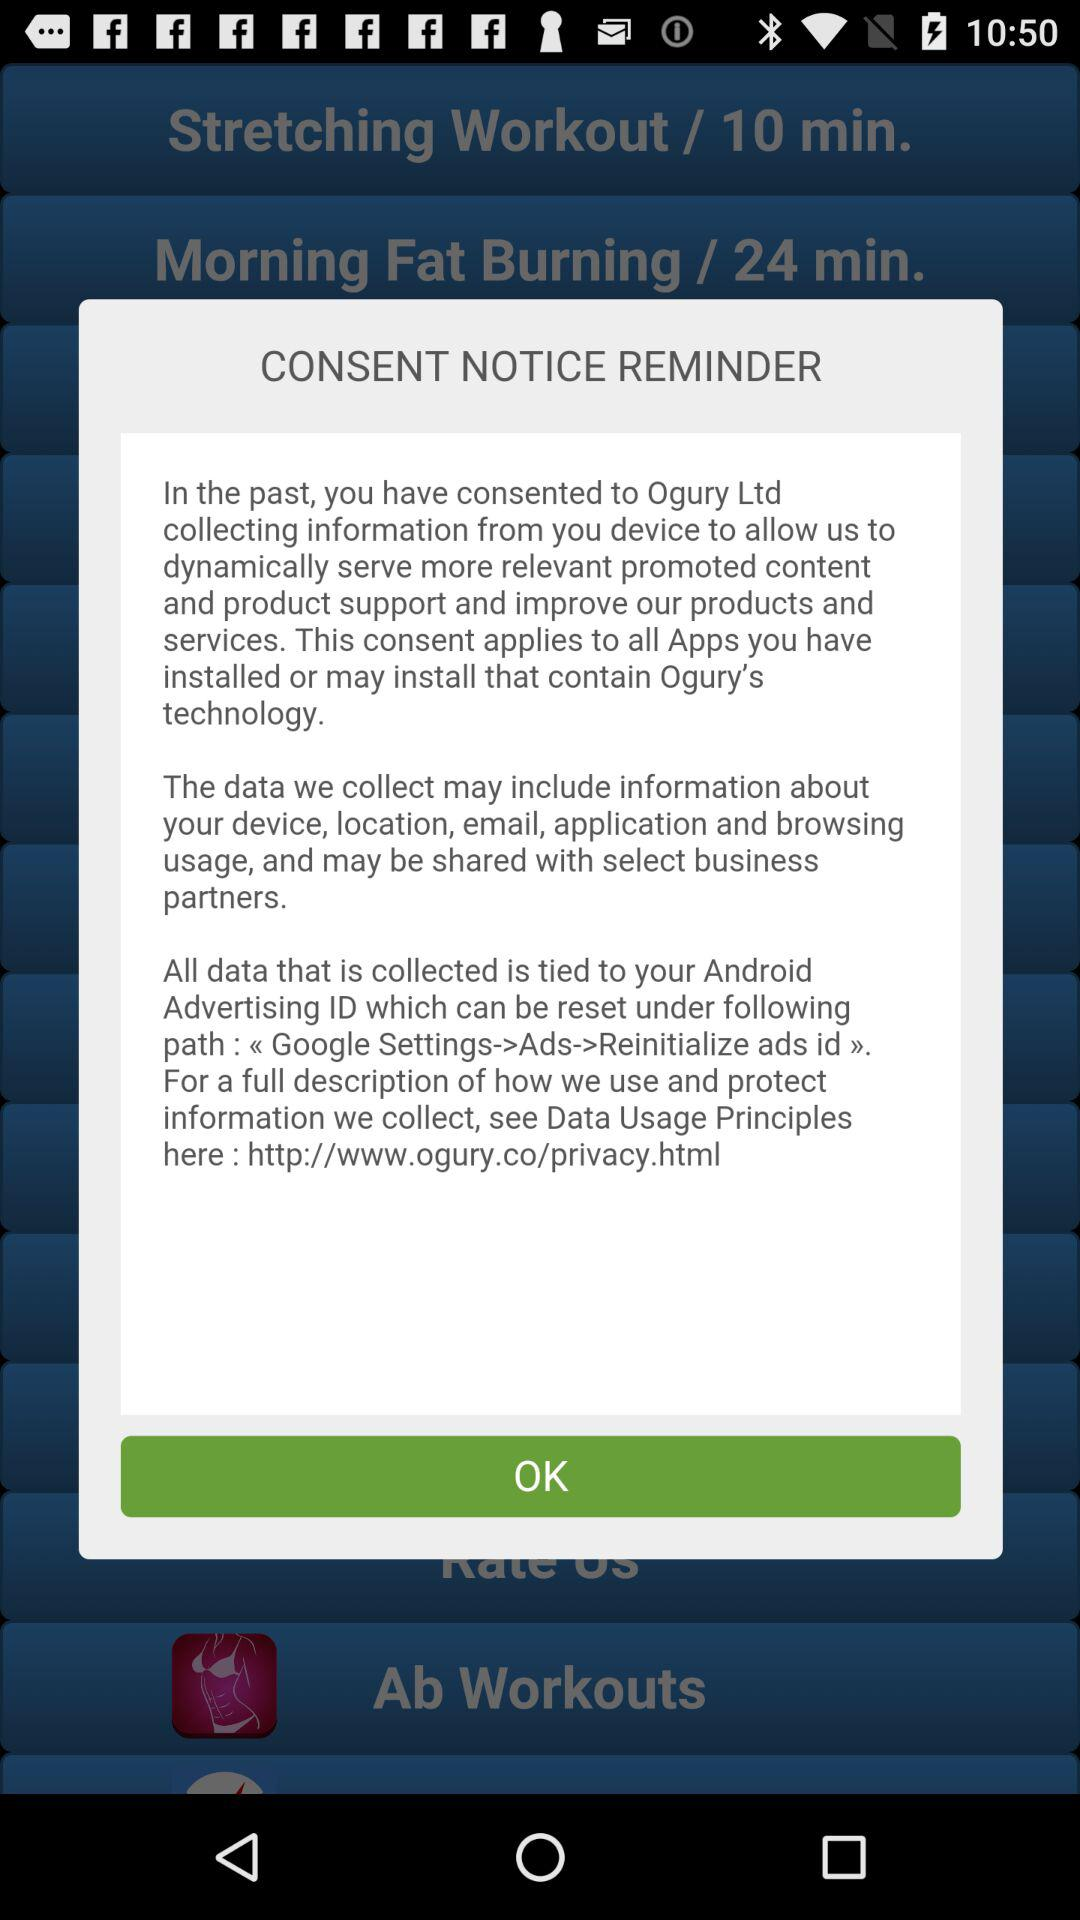Where will all data be collected?
When the provided information is insufficient, respond with <no answer>. <no answer> 